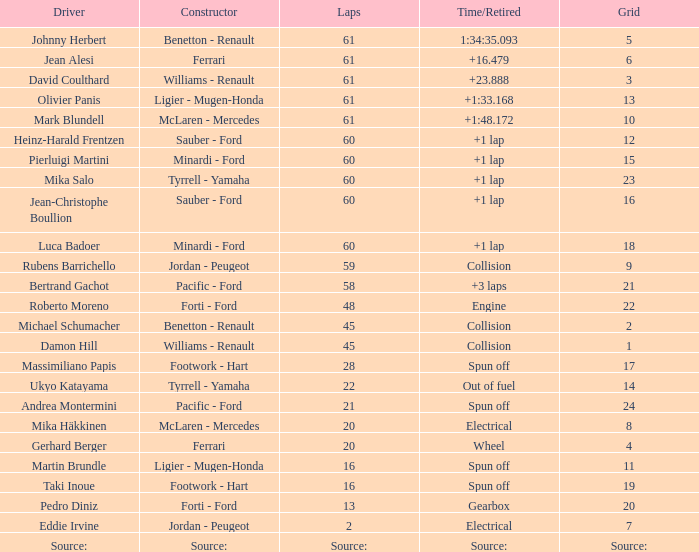What grid features 2 rounds? 7.0. 